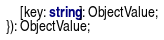<code> <loc_0><loc_0><loc_500><loc_500><_TypeScript_>    [key: string]: ObjectValue;
}): ObjectValue;
</code> 